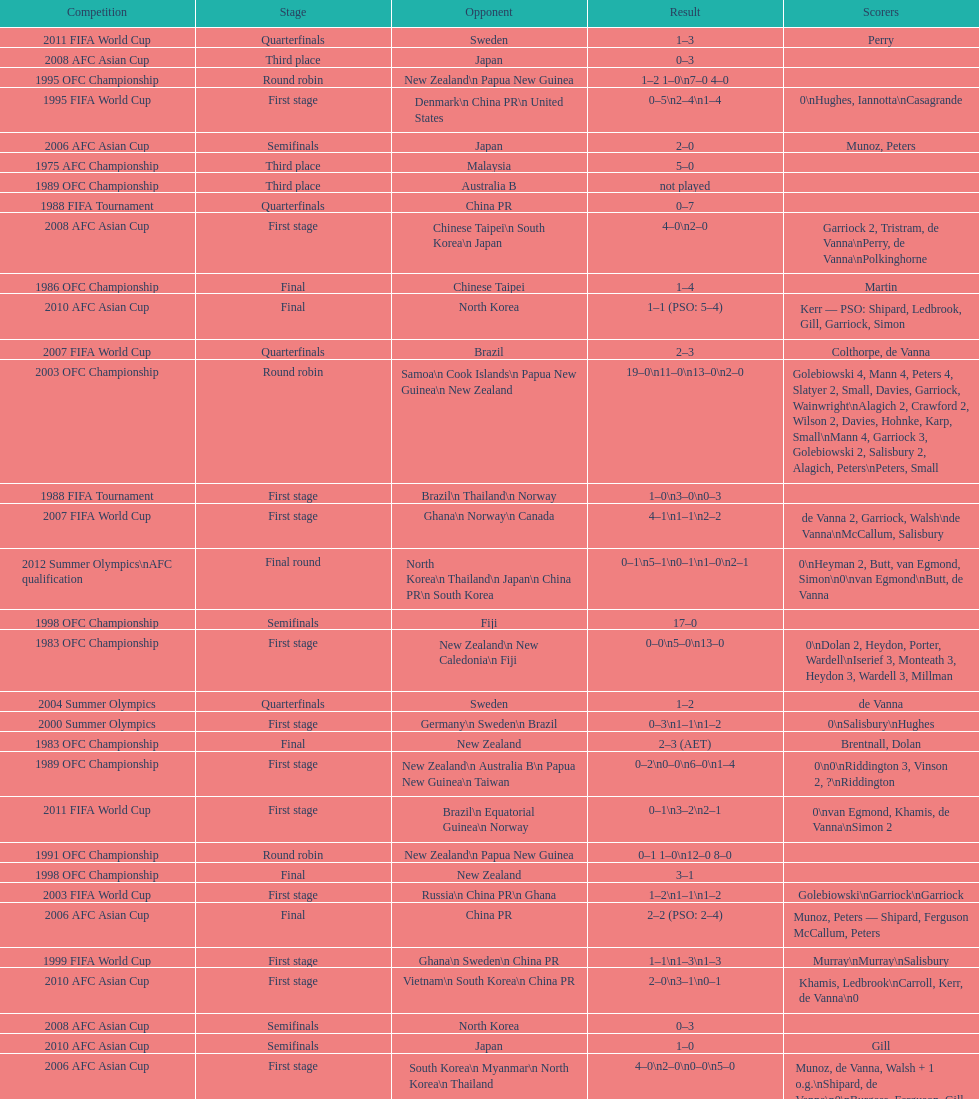Can you give me this table as a dict? {'header': ['Competition', 'Stage', 'Opponent', 'Result', 'Scorers'], 'rows': [['2011 FIFA World Cup', 'Quarterfinals', 'Sweden', '1–3', 'Perry'], ['2008 AFC Asian Cup', 'Third place', 'Japan', '0–3', ''], ['1995 OFC Championship', 'Round robin', 'New Zealand\\n\xa0Papua New Guinea', '1–2 1–0\\n7–0 4–0', ''], ['1995 FIFA World Cup', 'First stage', 'Denmark\\n\xa0China PR\\n\xa0United States', '0–5\\n2–4\\n1–4', '0\\nHughes, Iannotta\\nCasagrande'], ['2006 AFC Asian Cup', 'Semifinals', 'Japan', '2–0', 'Munoz, Peters'], ['1975 AFC Championship', 'Third place', 'Malaysia', '5–0', ''], ['1989 OFC Championship', 'Third place', 'Australia B', 'not played', ''], ['1988 FIFA Tournament', 'Quarterfinals', 'China PR', '0–7', ''], ['2008 AFC Asian Cup', 'First stage', 'Chinese Taipei\\n\xa0South Korea\\n\xa0Japan', '4–0\\n2–0', 'Garriock 2, Tristram, de Vanna\\nPerry, de Vanna\\nPolkinghorne'], ['1986 OFC Championship', 'Final', 'Chinese Taipei', '1–4', 'Martin'], ['2010 AFC Asian Cup', 'Final', 'North Korea', '1–1 (PSO: 5–4)', 'Kerr — PSO: Shipard, Ledbrook, Gill, Garriock, Simon'], ['2007 FIFA World Cup', 'Quarterfinals', 'Brazil', '2–3', 'Colthorpe, de Vanna'], ['2003 OFC Championship', 'Round robin', 'Samoa\\n\xa0Cook Islands\\n\xa0Papua New Guinea\\n\xa0New Zealand', '19–0\\n11–0\\n13–0\\n2–0', 'Golebiowski 4, Mann 4, Peters 4, Slatyer 2, Small, Davies, Garriock, Wainwright\\nAlagich 2, Crawford 2, Wilson 2, Davies, Hohnke, Karp, Small\\nMann 4, Garriock 3, Golebiowski 2, Salisbury 2, Alagich, Peters\\nPeters, Small'], ['1988 FIFA Tournament', 'First stage', 'Brazil\\n\xa0Thailand\\n\xa0Norway', '1–0\\n3–0\\n0–3', ''], ['2007 FIFA World Cup', 'First stage', 'Ghana\\n\xa0Norway\\n\xa0Canada', '4–1\\n1–1\\n2–2', 'de Vanna 2, Garriock, Walsh\\nde Vanna\\nMcCallum, Salisbury'], ['2012 Summer Olympics\\nAFC qualification', 'Final round', 'North Korea\\n\xa0Thailand\\n\xa0Japan\\n\xa0China PR\\n\xa0South Korea', '0–1\\n5–1\\n0–1\\n1–0\\n2–1', '0\\nHeyman 2, Butt, van Egmond, Simon\\n0\\nvan Egmond\\nButt, de Vanna'], ['1998 OFC Championship', 'Semifinals', 'Fiji', '17–0', ''], ['1983 OFC Championship', 'First stage', 'New Zealand\\n\xa0New Caledonia\\n\xa0Fiji', '0–0\\n5–0\\n13–0', '0\\nDolan 2, Heydon, Porter, Wardell\\nIserief 3, Monteath 3, Heydon 3, Wardell 3, Millman'], ['2004 Summer Olympics', 'Quarterfinals', 'Sweden', '1–2', 'de Vanna'], ['2000 Summer Olympics', 'First stage', 'Germany\\n\xa0Sweden\\n\xa0Brazil', '0–3\\n1–1\\n1–2', '0\\nSalisbury\\nHughes'], ['1983 OFC Championship', 'Final', 'New Zealand', '2–3 (AET)', 'Brentnall, Dolan'], ['1989 OFC Championship', 'First stage', 'New Zealand\\n Australia B\\n\xa0Papua New Guinea\\n\xa0Taiwan', '0–2\\n0–0\\n6–0\\n1–4', '0\\n0\\nRiddington 3, Vinson 2,\xa0?\\nRiddington'], ['2011 FIFA World Cup', 'First stage', 'Brazil\\n\xa0Equatorial Guinea\\n\xa0Norway', '0–1\\n3–2\\n2–1', '0\\nvan Egmond, Khamis, de Vanna\\nSimon 2'], ['1991 OFC Championship', 'Round robin', 'New Zealand\\n\xa0Papua New Guinea', '0–1 1–0\\n12–0 8–0', ''], ['1998 OFC Championship', 'Final', 'New Zealand', '3–1', ''], ['2003 FIFA World Cup', 'First stage', 'Russia\\n\xa0China PR\\n\xa0Ghana', '1–2\\n1–1\\n1–2', 'Golebiowski\\nGarriock\\nGarriock'], ['2006 AFC Asian Cup', 'Final', 'China PR', '2–2 (PSO: 2–4)', 'Munoz, Peters — Shipard, Ferguson McCallum, Peters'], ['1999 FIFA World Cup', 'First stage', 'Ghana\\n\xa0Sweden\\n\xa0China PR', '1–1\\n1–3\\n1–3', 'Murray\\nMurray\\nSalisbury'], ['2010 AFC Asian Cup', 'First stage', 'Vietnam\\n\xa0South Korea\\n\xa0China PR', '2–0\\n3–1\\n0–1', 'Khamis, Ledbrook\\nCarroll, Kerr, de Vanna\\n0'], ['2008 AFC Asian Cup', 'Semifinals', 'North Korea', '0–3', ''], ['2010 AFC Asian Cup', 'Semifinals', 'Japan', '1–0', 'Gill'], ['2006 AFC Asian Cup', 'First stage', 'South Korea\\n\xa0Myanmar\\n\xa0North Korea\\n\xa0Thailand', '4–0\\n2–0\\n0–0\\n5–0', 'Munoz, de Vanna, Walsh + 1 o.g.\\nShipard, de Vanna\\n0\\nBurgess, Ferguson, Gill, de Vanna, Walsh'], ['1975 AFC Championship', 'First stage', 'Thailand\\n\xa0Singapore', '2–3\\n3–0', ''], ['1975 AFC Championship', 'Semifinals', 'New Zealand', '2–3', ''], ['1986 OFC Championship', 'First stage', 'New Zealand\\n\xa0Chinese Taipei\\n New Zealand B', '1–0\\n0–1\\n2–1', 'Iserief\\n0\\nMateljan, Monteath'], ['1998 OFC Championship', 'First stage', 'American Samoa\\n\xa0Papua New Guinea', '21–0\\n8–0', ''], ['2014 AFC Asian Cup', 'First stage', 'Japan\\n\xa0Jordan\\n\xa0Vietnam', 'TBD\\nTBD\\nTBD', ''], ['2004 Summer Olympics', 'First stage', 'Brazil\\n\xa0Greece\\n\xa0United States', '0–1\\n1–0\\n1–1', '0\\nGarriock\\nPeters']]} What is the total number of competitions? 21. 